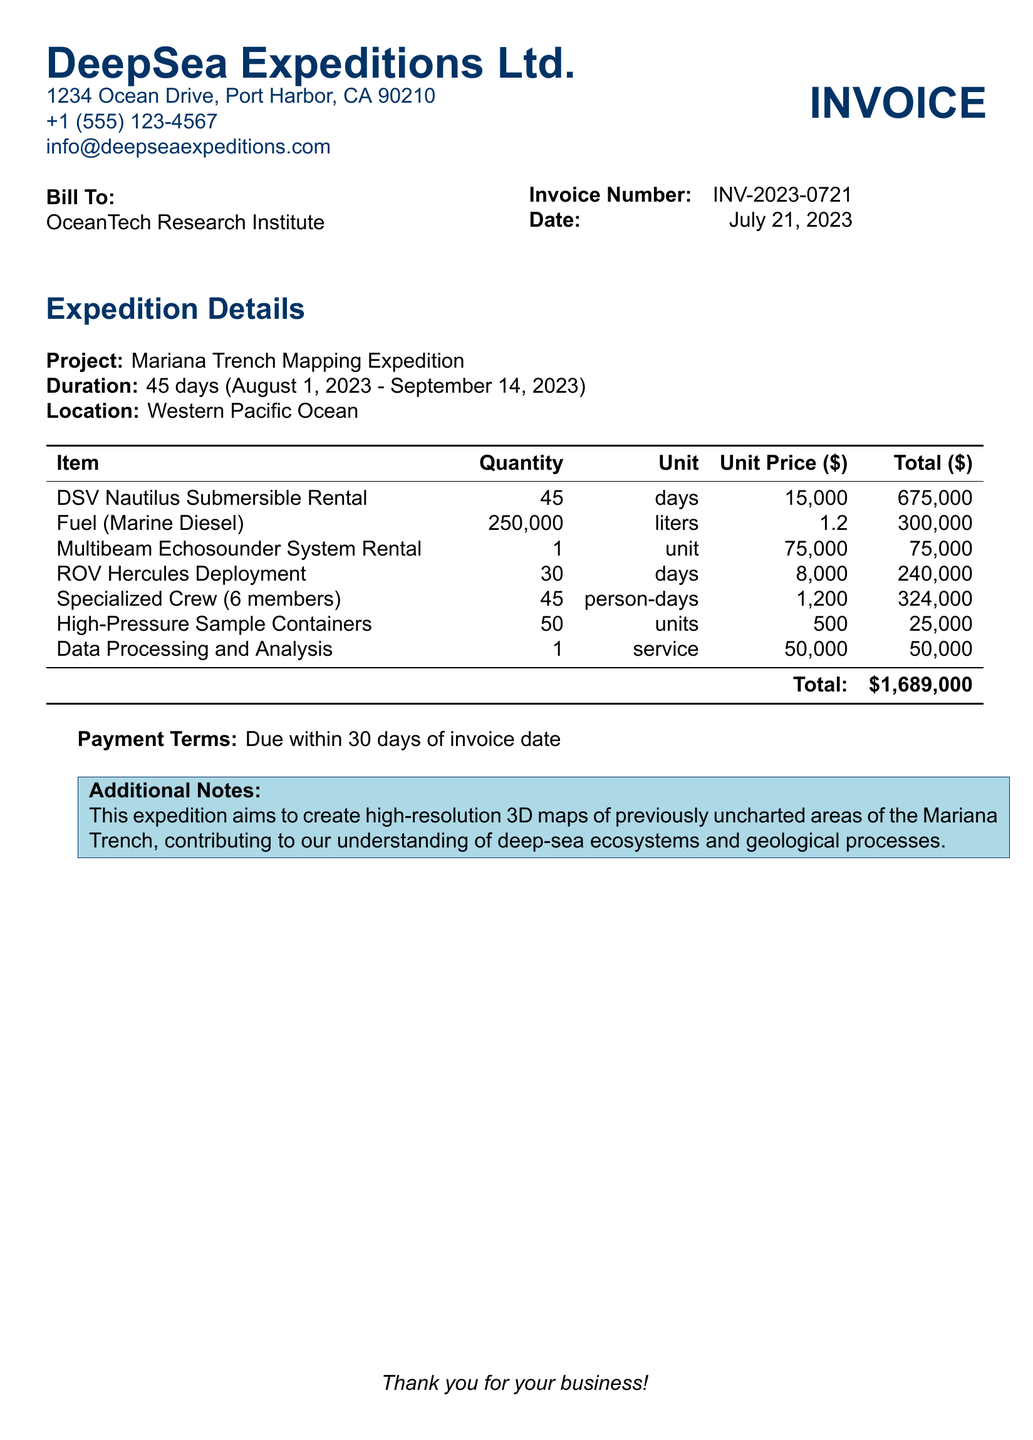what is the invoice number? The invoice number is specified in the document and is found under the details section for billing.
Answer: INV-2023-0721 what is the duration of the expedition? The duration is mentioned directly as the period over which the expedition takes place, listed in days.
Answer: 45 days how much does the rental of the DSV Nautilus Submersible cost? The cost for renting the DSV Nautilus per day is clearly indicated in the unit price section of the bill.
Answer: 15,000 what is the total amount billed? The total amount billed can be found at the bottom of the cost table and summarizes all expenses incurred during the expedition.
Answer: $1,689,000 how many liters of fuel are needed for the expedition? The document specifies the quantity of fuel required for the expedition in liters.
Answer: 250,000 liters how many members are in the specialized crew? The number of specialized crew members is stated directly under the item listing for specialized crew.
Answer: 6 members what service is required for data processing? This section describes the necessity of a service for processing and analyzing expedition data and is included in the items list.
Answer: Data Processing and Analysis when is the payment due? The payment terms section of the document specifies when the payment should be made relative to the invoice date.
Answer: 30 days what is the project name? The document clearly states the name of the project associated with the invoice at the beginning of the expedition details section.
Answer: Mariana Trench Mapping Expedition 